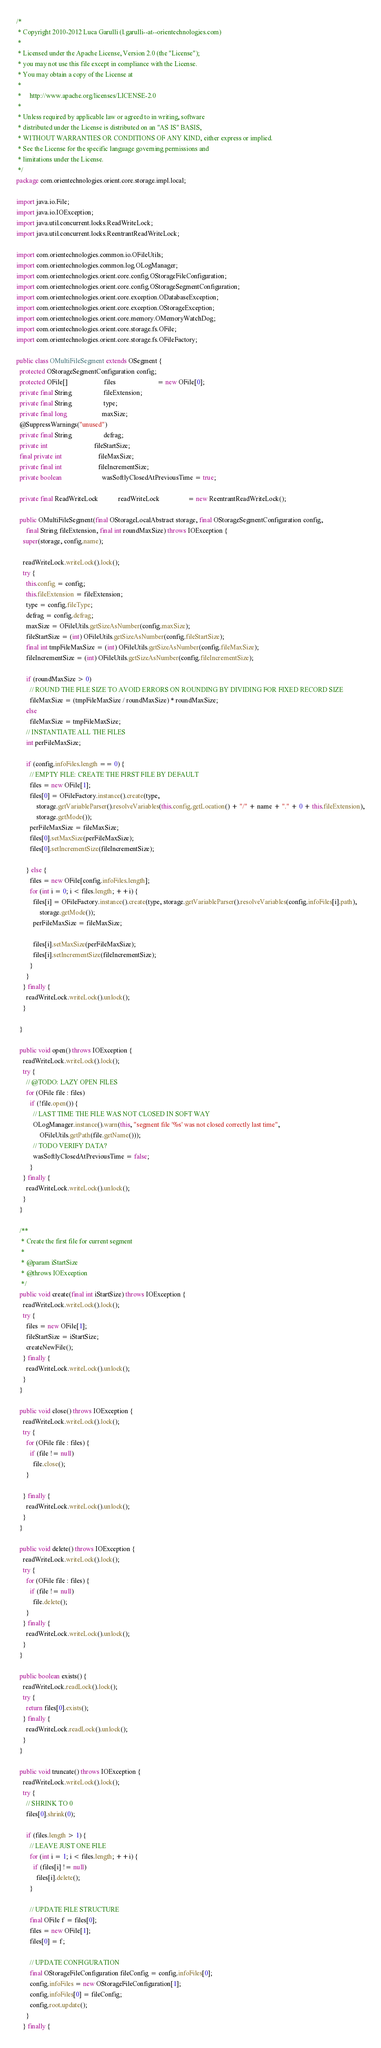Convert code to text. <code><loc_0><loc_0><loc_500><loc_500><_Java_>/*
 * Copyright 2010-2012 Luca Garulli (l.garulli--at--orientechnologies.com)
 *
 * Licensed under the Apache License, Version 2.0 (the "License");
 * you may not use this file except in compliance with the License.
 * You may obtain a copy of the License at
 *
 *     http://www.apache.org/licenses/LICENSE-2.0
 *
 * Unless required by applicable law or agreed to in writing, software
 * distributed under the License is distributed on an "AS IS" BASIS,
 * WITHOUT WARRANTIES OR CONDITIONS OF ANY KIND, either express or implied.
 * See the License for the specific language governing permissions and
 * limitations under the License.
 */
package com.orientechnologies.orient.core.storage.impl.local;

import java.io.File;
import java.io.IOException;
import java.util.concurrent.locks.ReadWriteLock;
import java.util.concurrent.locks.ReentrantReadWriteLock;

import com.orientechnologies.common.io.OFileUtils;
import com.orientechnologies.common.log.OLogManager;
import com.orientechnologies.orient.core.config.OStorageFileConfiguration;
import com.orientechnologies.orient.core.config.OStorageSegmentConfiguration;
import com.orientechnologies.orient.core.exception.ODatabaseException;
import com.orientechnologies.orient.core.exception.OStorageException;
import com.orientechnologies.orient.core.memory.OMemoryWatchDog;
import com.orientechnologies.orient.core.storage.fs.OFile;
import com.orientechnologies.orient.core.storage.fs.OFileFactory;

public class OMultiFileSegment extends OSegment {
  protected OStorageSegmentConfiguration config;
  protected OFile[]                      files                         = new OFile[0];
  private final String                   fileExtension;
  private final String                   type;
  private final long                     maxSize;
  @SuppressWarnings("unused")
  private final String                   defrag;
  private int                            fileStartSize;
  final private int                      fileMaxSize;
  private final int                      fileIncrementSize;
  private boolean                        wasSoftlyClosedAtPreviousTime = true;

  private final ReadWriteLock            readWriteLock                 = new ReentrantReadWriteLock();

  public OMultiFileSegment(final OStorageLocalAbstract storage, final OStorageSegmentConfiguration config,
      final String fileExtension, final int roundMaxSize) throws IOException {
    super(storage, config.name);

    readWriteLock.writeLock().lock();
    try {
      this.config = config;
      this.fileExtension = fileExtension;
      type = config.fileType;
      defrag = config.defrag;
      maxSize = OFileUtils.getSizeAsNumber(config.maxSize);
      fileStartSize = (int) OFileUtils.getSizeAsNumber(config.fileStartSize);
      final int tmpFileMaxSize = (int) OFileUtils.getSizeAsNumber(config.fileMaxSize);
      fileIncrementSize = (int) OFileUtils.getSizeAsNumber(config.fileIncrementSize);

      if (roundMaxSize > 0)
        // ROUND THE FILE SIZE TO AVOID ERRORS ON ROUNDING BY DIVIDING FOR FIXED RECORD SIZE
        fileMaxSize = (tmpFileMaxSize / roundMaxSize) * roundMaxSize;
      else
        fileMaxSize = tmpFileMaxSize;
      // INSTANTIATE ALL THE FILES
      int perFileMaxSize;

      if (config.infoFiles.length == 0) {
        // EMPTY FILE: CREATE THE FIRST FILE BY DEFAULT
        files = new OFile[1];
        files[0] = OFileFactory.instance().create(type,
            storage.getVariableParser().resolveVariables(this.config.getLocation() + "/" + name + "." + 0 + this.fileExtension),
            storage.getMode());
        perFileMaxSize = fileMaxSize;
        files[0].setMaxSize(perFileMaxSize);
        files[0].setIncrementSize(fileIncrementSize);

      } else {
        files = new OFile[config.infoFiles.length];
        for (int i = 0; i < files.length; ++i) {
          files[i] = OFileFactory.instance().create(type, storage.getVariableParser().resolveVariables(config.infoFiles[i].path),
              storage.getMode());
          perFileMaxSize = fileMaxSize;

          files[i].setMaxSize(perFileMaxSize);
          files[i].setIncrementSize(fileIncrementSize);
        }
      }
    } finally {
      readWriteLock.writeLock().unlock();
    }

  }

  public void open() throws IOException {
    readWriteLock.writeLock().lock();
    try {
      // @TODO: LAZY OPEN FILES
      for (OFile file : files)
        if (!file.open()) {
          // LAST TIME THE FILE WAS NOT CLOSED IN SOFT WAY
          OLogManager.instance().warn(this, "segment file '%s' was not closed correctly last time",
              OFileUtils.getPath(file.getName()));
          // TODO VERIFY DATA?
          wasSoftlyClosedAtPreviousTime = false;
        }
    } finally {
      readWriteLock.writeLock().unlock();
    }
  }

  /**
   * Create the first file for current segment
   * 
   * @param iStartSize
   * @throws IOException
   */
  public void create(final int iStartSize) throws IOException {
    readWriteLock.writeLock().lock();
    try {
      files = new OFile[1];
      fileStartSize = iStartSize;
      createNewFile();
    } finally {
      readWriteLock.writeLock().unlock();
    }
  }

  public void close() throws IOException {
    readWriteLock.writeLock().lock();
    try {
      for (OFile file : files) {
        if (file != null)
          file.close();
      }

    } finally {
      readWriteLock.writeLock().unlock();
    }
  }

  public void delete() throws IOException {
    readWriteLock.writeLock().lock();
    try {
      for (OFile file : files) {
        if (file != null)
          file.delete();
      }
    } finally {
      readWriteLock.writeLock().unlock();
    }
  }

  public boolean exists() {
    readWriteLock.readLock().lock();
    try {
      return files[0].exists();
    } finally {
      readWriteLock.readLock().unlock();
    }
  }

  public void truncate() throws IOException {
    readWriteLock.writeLock().lock();
    try {
      // SHRINK TO 0
      files[0].shrink(0);

      if (files.length > 1) {
        // LEAVE JUST ONE FILE
        for (int i = 1; i < files.length; ++i) {
          if (files[i] != null)
            files[i].delete();
        }

        // UPDATE FILE STRUCTURE
        final OFile f = files[0];
        files = new OFile[1];
        files[0] = f;

        // UPDATE CONFIGURATION
        final OStorageFileConfiguration fileConfig = config.infoFiles[0];
        config.infoFiles = new OStorageFileConfiguration[1];
        config.infoFiles[0] = fileConfig;
        config.root.update();
      }
    } finally {</code> 